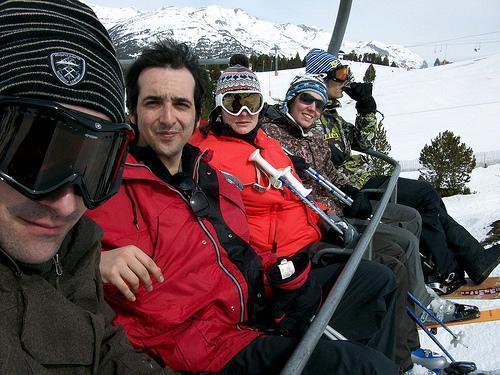How many skiers are wearing red jackets?
Give a very brief answer. 2. How many people are not wearing goggles?
Give a very brief answer. 1. 